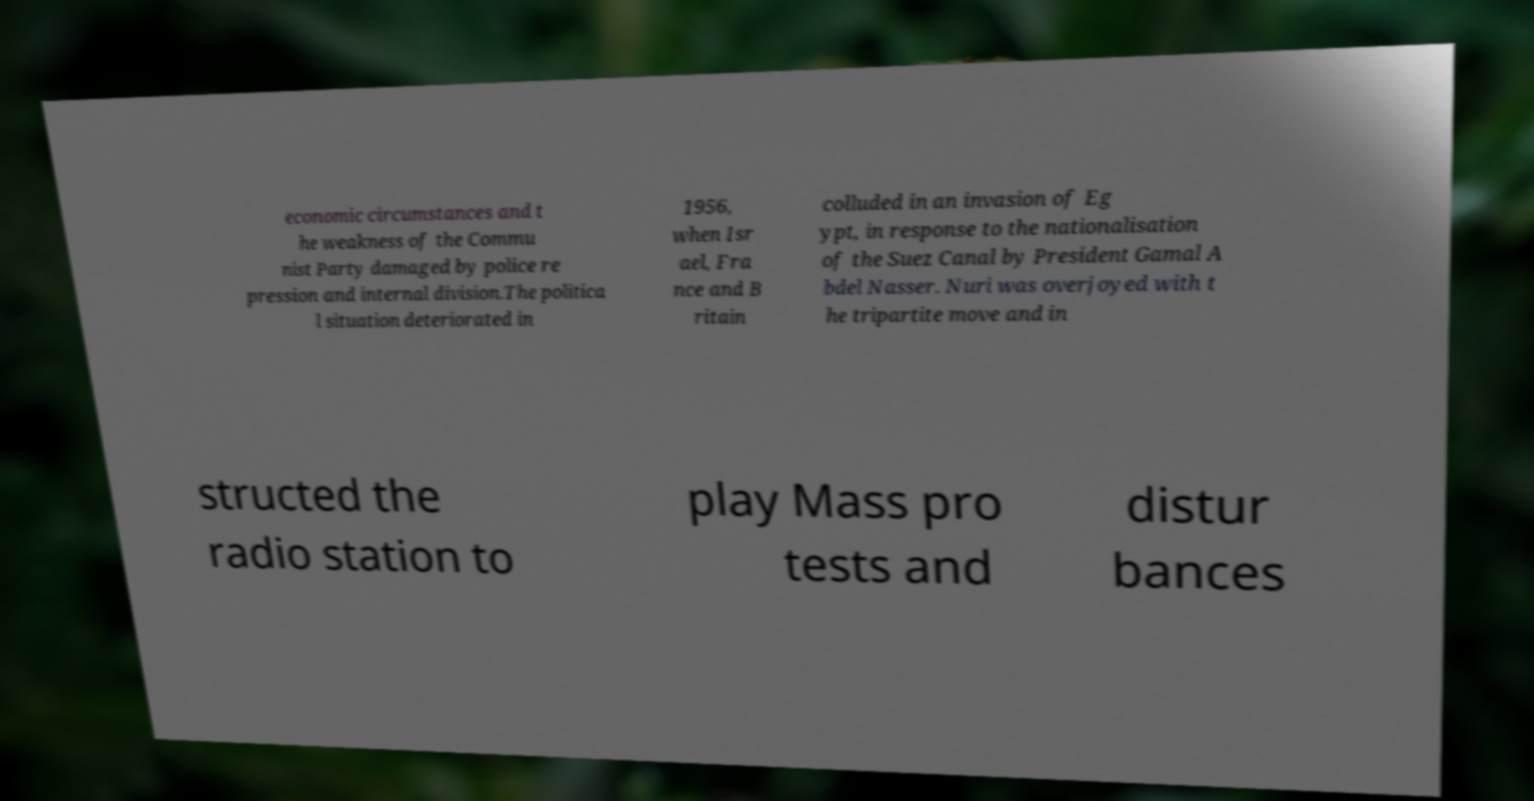Can you accurately transcribe the text from the provided image for me? economic circumstances and t he weakness of the Commu nist Party damaged by police re pression and internal division.The politica l situation deteriorated in 1956, when Isr ael, Fra nce and B ritain colluded in an invasion of Eg ypt, in response to the nationalisation of the Suez Canal by President Gamal A bdel Nasser. Nuri was overjoyed with t he tripartite move and in structed the radio station to play Mass pro tests and distur bances 